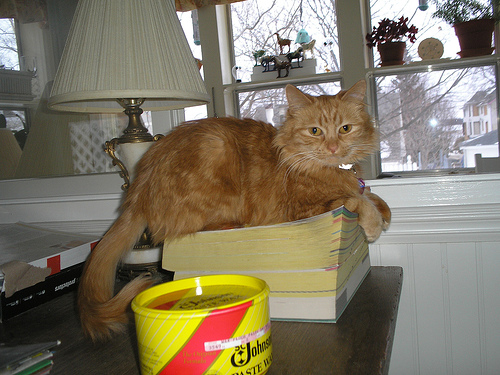<image>
Is the cat behind the can? Yes. From this viewpoint, the cat is positioned behind the can, with the can partially or fully occluding the cat. 